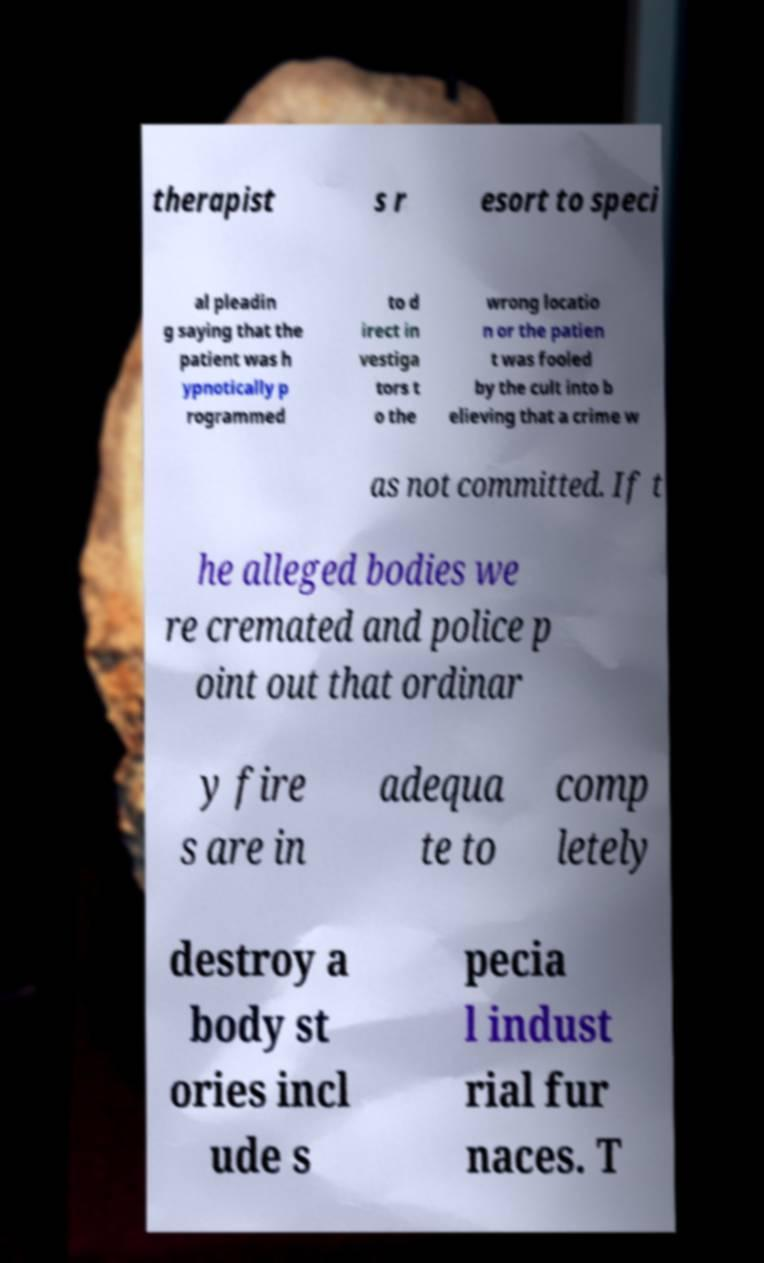Could you assist in decoding the text presented in this image and type it out clearly? therapist s r esort to speci al pleadin g saying that the patient was h ypnotically p rogrammed to d irect in vestiga tors t o the wrong locatio n or the patien t was fooled by the cult into b elieving that a crime w as not committed. If t he alleged bodies we re cremated and police p oint out that ordinar y fire s are in adequa te to comp letely destroy a body st ories incl ude s pecia l indust rial fur naces. T 